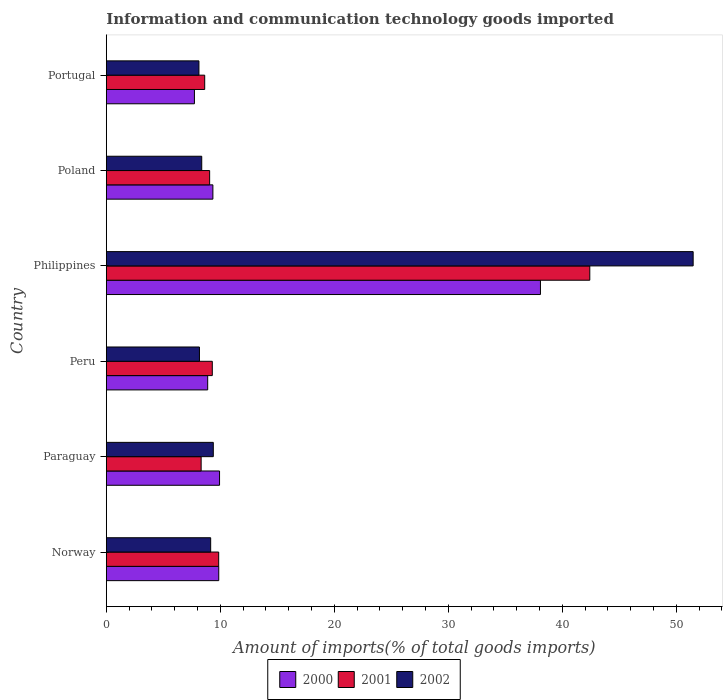How many different coloured bars are there?
Give a very brief answer. 3. Are the number of bars on each tick of the Y-axis equal?
Ensure brevity in your answer.  Yes. How many bars are there on the 2nd tick from the bottom?
Keep it short and to the point. 3. What is the label of the 6th group of bars from the top?
Give a very brief answer. Norway. What is the amount of goods imported in 2000 in Paraguay?
Provide a short and direct response. 9.93. Across all countries, what is the maximum amount of goods imported in 2000?
Offer a terse response. 38.08. Across all countries, what is the minimum amount of goods imported in 2000?
Your answer should be very brief. 7.73. What is the total amount of goods imported in 2001 in the graph?
Make the answer very short. 87.57. What is the difference between the amount of goods imported in 2001 in Philippines and that in Portugal?
Make the answer very short. 33.78. What is the difference between the amount of goods imported in 2000 in Norway and the amount of goods imported in 2001 in Portugal?
Your response must be concise. 1.23. What is the average amount of goods imported in 2002 per country?
Offer a very short reply. 15.78. What is the difference between the amount of goods imported in 2001 and amount of goods imported in 2000 in Norway?
Your answer should be compact. -0.01. What is the ratio of the amount of goods imported in 2002 in Norway to that in Peru?
Ensure brevity in your answer.  1.12. Is the amount of goods imported in 2001 in Peru less than that in Philippines?
Give a very brief answer. Yes. What is the difference between the highest and the second highest amount of goods imported in 2000?
Offer a very short reply. 28.15. What is the difference between the highest and the lowest amount of goods imported in 2001?
Your answer should be very brief. 34.09. In how many countries, is the amount of goods imported in 2001 greater than the average amount of goods imported in 2001 taken over all countries?
Your answer should be very brief. 1. Is the sum of the amount of goods imported in 2002 in Philippines and Portugal greater than the maximum amount of goods imported in 2001 across all countries?
Provide a succinct answer. Yes. Is it the case that in every country, the sum of the amount of goods imported in 2000 and amount of goods imported in 2001 is greater than the amount of goods imported in 2002?
Provide a short and direct response. Yes. How many bars are there?
Offer a very short reply. 18. How many countries are there in the graph?
Make the answer very short. 6. What is the difference between two consecutive major ticks on the X-axis?
Provide a short and direct response. 10. Are the values on the major ticks of X-axis written in scientific E-notation?
Offer a very short reply. No. Does the graph contain any zero values?
Your answer should be compact. No. What is the title of the graph?
Your answer should be very brief. Information and communication technology goods imported. Does "1974" appear as one of the legend labels in the graph?
Ensure brevity in your answer.  No. What is the label or title of the X-axis?
Your response must be concise. Amount of imports(% of total goods imports). What is the Amount of imports(% of total goods imports) in 2000 in Norway?
Offer a terse response. 9.86. What is the Amount of imports(% of total goods imports) in 2001 in Norway?
Ensure brevity in your answer.  9.86. What is the Amount of imports(% of total goods imports) of 2002 in Norway?
Give a very brief answer. 9.15. What is the Amount of imports(% of total goods imports) in 2000 in Paraguay?
Give a very brief answer. 9.93. What is the Amount of imports(% of total goods imports) of 2001 in Paraguay?
Offer a very short reply. 8.32. What is the Amount of imports(% of total goods imports) of 2002 in Paraguay?
Provide a succinct answer. 9.38. What is the Amount of imports(% of total goods imports) of 2000 in Peru?
Your answer should be compact. 8.89. What is the Amount of imports(% of total goods imports) in 2001 in Peru?
Your answer should be very brief. 9.3. What is the Amount of imports(% of total goods imports) of 2002 in Peru?
Give a very brief answer. 8.17. What is the Amount of imports(% of total goods imports) of 2000 in Philippines?
Provide a succinct answer. 38.08. What is the Amount of imports(% of total goods imports) in 2001 in Philippines?
Provide a short and direct response. 42.41. What is the Amount of imports(% of total goods imports) in 2002 in Philippines?
Your answer should be very brief. 51.48. What is the Amount of imports(% of total goods imports) in 2000 in Poland?
Give a very brief answer. 9.35. What is the Amount of imports(% of total goods imports) of 2001 in Poland?
Your answer should be very brief. 9.06. What is the Amount of imports(% of total goods imports) in 2002 in Poland?
Ensure brevity in your answer.  8.37. What is the Amount of imports(% of total goods imports) of 2000 in Portugal?
Ensure brevity in your answer.  7.73. What is the Amount of imports(% of total goods imports) in 2001 in Portugal?
Keep it short and to the point. 8.63. What is the Amount of imports(% of total goods imports) in 2002 in Portugal?
Give a very brief answer. 8.12. Across all countries, what is the maximum Amount of imports(% of total goods imports) in 2000?
Your answer should be compact. 38.08. Across all countries, what is the maximum Amount of imports(% of total goods imports) of 2001?
Your answer should be compact. 42.41. Across all countries, what is the maximum Amount of imports(% of total goods imports) in 2002?
Offer a terse response. 51.48. Across all countries, what is the minimum Amount of imports(% of total goods imports) of 2000?
Make the answer very short. 7.73. Across all countries, what is the minimum Amount of imports(% of total goods imports) in 2001?
Your answer should be compact. 8.32. Across all countries, what is the minimum Amount of imports(% of total goods imports) of 2002?
Ensure brevity in your answer.  8.12. What is the total Amount of imports(% of total goods imports) of 2000 in the graph?
Your answer should be compact. 83.84. What is the total Amount of imports(% of total goods imports) in 2001 in the graph?
Provide a short and direct response. 87.57. What is the total Amount of imports(% of total goods imports) of 2002 in the graph?
Keep it short and to the point. 94.67. What is the difference between the Amount of imports(% of total goods imports) of 2000 in Norway and that in Paraguay?
Offer a terse response. -0.07. What is the difference between the Amount of imports(% of total goods imports) of 2001 in Norway and that in Paraguay?
Your answer should be very brief. 1.54. What is the difference between the Amount of imports(% of total goods imports) in 2002 in Norway and that in Paraguay?
Provide a short and direct response. -0.23. What is the difference between the Amount of imports(% of total goods imports) in 2000 in Norway and that in Peru?
Your answer should be compact. 0.97. What is the difference between the Amount of imports(% of total goods imports) of 2001 in Norway and that in Peru?
Your answer should be very brief. 0.56. What is the difference between the Amount of imports(% of total goods imports) of 2002 in Norway and that in Peru?
Give a very brief answer. 0.98. What is the difference between the Amount of imports(% of total goods imports) in 2000 in Norway and that in Philippines?
Offer a terse response. -28.22. What is the difference between the Amount of imports(% of total goods imports) of 2001 in Norway and that in Philippines?
Offer a very short reply. -32.56. What is the difference between the Amount of imports(% of total goods imports) in 2002 in Norway and that in Philippines?
Provide a short and direct response. -42.32. What is the difference between the Amount of imports(% of total goods imports) in 2000 in Norway and that in Poland?
Make the answer very short. 0.51. What is the difference between the Amount of imports(% of total goods imports) of 2001 in Norway and that in Poland?
Keep it short and to the point. 0.79. What is the difference between the Amount of imports(% of total goods imports) of 2002 in Norway and that in Poland?
Your response must be concise. 0.78. What is the difference between the Amount of imports(% of total goods imports) of 2000 in Norway and that in Portugal?
Your answer should be very brief. 2.14. What is the difference between the Amount of imports(% of total goods imports) in 2001 in Norway and that in Portugal?
Offer a very short reply. 1.23. What is the difference between the Amount of imports(% of total goods imports) in 2002 in Norway and that in Portugal?
Ensure brevity in your answer.  1.03. What is the difference between the Amount of imports(% of total goods imports) in 2000 in Paraguay and that in Peru?
Ensure brevity in your answer.  1.04. What is the difference between the Amount of imports(% of total goods imports) in 2001 in Paraguay and that in Peru?
Your answer should be very brief. -0.98. What is the difference between the Amount of imports(% of total goods imports) in 2002 in Paraguay and that in Peru?
Your answer should be very brief. 1.21. What is the difference between the Amount of imports(% of total goods imports) in 2000 in Paraguay and that in Philippines?
Offer a very short reply. -28.15. What is the difference between the Amount of imports(% of total goods imports) in 2001 in Paraguay and that in Philippines?
Give a very brief answer. -34.09. What is the difference between the Amount of imports(% of total goods imports) of 2002 in Paraguay and that in Philippines?
Your response must be concise. -42.09. What is the difference between the Amount of imports(% of total goods imports) in 2000 in Paraguay and that in Poland?
Keep it short and to the point. 0.58. What is the difference between the Amount of imports(% of total goods imports) in 2001 in Paraguay and that in Poland?
Ensure brevity in your answer.  -0.75. What is the difference between the Amount of imports(% of total goods imports) in 2002 in Paraguay and that in Poland?
Offer a terse response. 1.01. What is the difference between the Amount of imports(% of total goods imports) in 2000 in Paraguay and that in Portugal?
Offer a very short reply. 2.2. What is the difference between the Amount of imports(% of total goods imports) in 2001 in Paraguay and that in Portugal?
Give a very brief answer. -0.31. What is the difference between the Amount of imports(% of total goods imports) of 2002 in Paraguay and that in Portugal?
Provide a succinct answer. 1.26. What is the difference between the Amount of imports(% of total goods imports) of 2000 in Peru and that in Philippines?
Provide a short and direct response. -29.19. What is the difference between the Amount of imports(% of total goods imports) of 2001 in Peru and that in Philippines?
Provide a succinct answer. -33.12. What is the difference between the Amount of imports(% of total goods imports) in 2002 in Peru and that in Philippines?
Offer a very short reply. -43.31. What is the difference between the Amount of imports(% of total goods imports) of 2000 in Peru and that in Poland?
Your answer should be very brief. -0.46. What is the difference between the Amount of imports(% of total goods imports) in 2001 in Peru and that in Poland?
Your answer should be compact. 0.23. What is the difference between the Amount of imports(% of total goods imports) of 2002 in Peru and that in Poland?
Offer a terse response. -0.2. What is the difference between the Amount of imports(% of total goods imports) in 2000 in Peru and that in Portugal?
Give a very brief answer. 1.16. What is the difference between the Amount of imports(% of total goods imports) in 2001 in Peru and that in Portugal?
Make the answer very short. 0.67. What is the difference between the Amount of imports(% of total goods imports) in 2002 in Peru and that in Portugal?
Offer a very short reply. 0.05. What is the difference between the Amount of imports(% of total goods imports) in 2000 in Philippines and that in Poland?
Give a very brief answer. 28.73. What is the difference between the Amount of imports(% of total goods imports) in 2001 in Philippines and that in Poland?
Provide a succinct answer. 33.35. What is the difference between the Amount of imports(% of total goods imports) of 2002 in Philippines and that in Poland?
Your answer should be compact. 43.11. What is the difference between the Amount of imports(% of total goods imports) in 2000 in Philippines and that in Portugal?
Make the answer very short. 30.36. What is the difference between the Amount of imports(% of total goods imports) in 2001 in Philippines and that in Portugal?
Make the answer very short. 33.78. What is the difference between the Amount of imports(% of total goods imports) of 2002 in Philippines and that in Portugal?
Offer a very short reply. 43.35. What is the difference between the Amount of imports(% of total goods imports) of 2000 in Poland and that in Portugal?
Your answer should be very brief. 1.62. What is the difference between the Amount of imports(% of total goods imports) in 2001 in Poland and that in Portugal?
Keep it short and to the point. 0.43. What is the difference between the Amount of imports(% of total goods imports) in 2002 in Poland and that in Portugal?
Ensure brevity in your answer.  0.25. What is the difference between the Amount of imports(% of total goods imports) of 2000 in Norway and the Amount of imports(% of total goods imports) of 2001 in Paraguay?
Your answer should be very brief. 1.55. What is the difference between the Amount of imports(% of total goods imports) of 2000 in Norway and the Amount of imports(% of total goods imports) of 2002 in Paraguay?
Offer a very short reply. 0.48. What is the difference between the Amount of imports(% of total goods imports) in 2001 in Norway and the Amount of imports(% of total goods imports) in 2002 in Paraguay?
Offer a very short reply. 0.47. What is the difference between the Amount of imports(% of total goods imports) of 2000 in Norway and the Amount of imports(% of total goods imports) of 2001 in Peru?
Your response must be concise. 0.57. What is the difference between the Amount of imports(% of total goods imports) of 2000 in Norway and the Amount of imports(% of total goods imports) of 2002 in Peru?
Provide a succinct answer. 1.69. What is the difference between the Amount of imports(% of total goods imports) of 2001 in Norway and the Amount of imports(% of total goods imports) of 2002 in Peru?
Offer a very short reply. 1.69. What is the difference between the Amount of imports(% of total goods imports) in 2000 in Norway and the Amount of imports(% of total goods imports) in 2001 in Philippines?
Provide a short and direct response. -32.55. What is the difference between the Amount of imports(% of total goods imports) of 2000 in Norway and the Amount of imports(% of total goods imports) of 2002 in Philippines?
Give a very brief answer. -41.62. What is the difference between the Amount of imports(% of total goods imports) of 2001 in Norway and the Amount of imports(% of total goods imports) of 2002 in Philippines?
Your answer should be very brief. -41.62. What is the difference between the Amount of imports(% of total goods imports) of 2000 in Norway and the Amount of imports(% of total goods imports) of 2001 in Poland?
Ensure brevity in your answer.  0.8. What is the difference between the Amount of imports(% of total goods imports) in 2000 in Norway and the Amount of imports(% of total goods imports) in 2002 in Poland?
Give a very brief answer. 1.49. What is the difference between the Amount of imports(% of total goods imports) in 2001 in Norway and the Amount of imports(% of total goods imports) in 2002 in Poland?
Your answer should be compact. 1.49. What is the difference between the Amount of imports(% of total goods imports) of 2000 in Norway and the Amount of imports(% of total goods imports) of 2001 in Portugal?
Ensure brevity in your answer.  1.23. What is the difference between the Amount of imports(% of total goods imports) of 2000 in Norway and the Amount of imports(% of total goods imports) of 2002 in Portugal?
Your response must be concise. 1.74. What is the difference between the Amount of imports(% of total goods imports) in 2001 in Norway and the Amount of imports(% of total goods imports) in 2002 in Portugal?
Provide a short and direct response. 1.73. What is the difference between the Amount of imports(% of total goods imports) in 2000 in Paraguay and the Amount of imports(% of total goods imports) in 2001 in Peru?
Offer a terse response. 0.64. What is the difference between the Amount of imports(% of total goods imports) of 2000 in Paraguay and the Amount of imports(% of total goods imports) of 2002 in Peru?
Offer a very short reply. 1.76. What is the difference between the Amount of imports(% of total goods imports) of 2001 in Paraguay and the Amount of imports(% of total goods imports) of 2002 in Peru?
Your answer should be compact. 0.15. What is the difference between the Amount of imports(% of total goods imports) in 2000 in Paraguay and the Amount of imports(% of total goods imports) in 2001 in Philippines?
Your answer should be compact. -32.48. What is the difference between the Amount of imports(% of total goods imports) in 2000 in Paraguay and the Amount of imports(% of total goods imports) in 2002 in Philippines?
Offer a very short reply. -41.55. What is the difference between the Amount of imports(% of total goods imports) in 2001 in Paraguay and the Amount of imports(% of total goods imports) in 2002 in Philippines?
Your response must be concise. -43.16. What is the difference between the Amount of imports(% of total goods imports) in 2000 in Paraguay and the Amount of imports(% of total goods imports) in 2001 in Poland?
Give a very brief answer. 0.87. What is the difference between the Amount of imports(% of total goods imports) of 2000 in Paraguay and the Amount of imports(% of total goods imports) of 2002 in Poland?
Your answer should be compact. 1.56. What is the difference between the Amount of imports(% of total goods imports) in 2001 in Paraguay and the Amount of imports(% of total goods imports) in 2002 in Poland?
Your answer should be very brief. -0.05. What is the difference between the Amount of imports(% of total goods imports) of 2000 in Paraguay and the Amount of imports(% of total goods imports) of 2001 in Portugal?
Give a very brief answer. 1.3. What is the difference between the Amount of imports(% of total goods imports) of 2000 in Paraguay and the Amount of imports(% of total goods imports) of 2002 in Portugal?
Your answer should be compact. 1.81. What is the difference between the Amount of imports(% of total goods imports) in 2001 in Paraguay and the Amount of imports(% of total goods imports) in 2002 in Portugal?
Your response must be concise. 0.19. What is the difference between the Amount of imports(% of total goods imports) in 2000 in Peru and the Amount of imports(% of total goods imports) in 2001 in Philippines?
Your response must be concise. -33.52. What is the difference between the Amount of imports(% of total goods imports) of 2000 in Peru and the Amount of imports(% of total goods imports) of 2002 in Philippines?
Offer a terse response. -42.59. What is the difference between the Amount of imports(% of total goods imports) of 2001 in Peru and the Amount of imports(% of total goods imports) of 2002 in Philippines?
Offer a terse response. -42.18. What is the difference between the Amount of imports(% of total goods imports) of 2000 in Peru and the Amount of imports(% of total goods imports) of 2001 in Poland?
Provide a succinct answer. -0.17. What is the difference between the Amount of imports(% of total goods imports) of 2000 in Peru and the Amount of imports(% of total goods imports) of 2002 in Poland?
Your answer should be very brief. 0.52. What is the difference between the Amount of imports(% of total goods imports) of 2001 in Peru and the Amount of imports(% of total goods imports) of 2002 in Poland?
Your answer should be very brief. 0.93. What is the difference between the Amount of imports(% of total goods imports) of 2000 in Peru and the Amount of imports(% of total goods imports) of 2001 in Portugal?
Give a very brief answer. 0.26. What is the difference between the Amount of imports(% of total goods imports) of 2000 in Peru and the Amount of imports(% of total goods imports) of 2002 in Portugal?
Make the answer very short. 0.77. What is the difference between the Amount of imports(% of total goods imports) in 2001 in Peru and the Amount of imports(% of total goods imports) in 2002 in Portugal?
Make the answer very short. 1.17. What is the difference between the Amount of imports(% of total goods imports) of 2000 in Philippines and the Amount of imports(% of total goods imports) of 2001 in Poland?
Give a very brief answer. 29.02. What is the difference between the Amount of imports(% of total goods imports) in 2000 in Philippines and the Amount of imports(% of total goods imports) in 2002 in Poland?
Ensure brevity in your answer.  29.71. What is the difference between the Amount of imports(% of total goods imports) in 2001 in Philippines and the Amount of imports(% of total goods imports) in 2002 in Poland?
Your answer should be compact. 34.04. What is the difference between the Amount of imports(% of total goods imports) in 2000 in Philippines and the Amount of imports(% of total goods imports) in 2001 in Portugal?
Give a very brief answer. 29.45. What is the difference between the Amount of imports(% of total goods imports) of 2000 in Philippines and the Amount of imports(% of total goods imports) of 2002 in Portugal?
Give a very brief answer. 29.96. What is the difference between the Amount of imports(% of total goods imports) of 2001 in Philippines and the Amount of imports(% of total goods imports) of 2002 in Portugal?
Keep it short and to the point. 34.29. What is the difference between the Amount of imports(% of total goods imports) of 2000 in Poland and the Amount of imports(% of total goods imports) of 2001 in Portugal?
Provide a short and direct response. 0.72. What is the difference between the Amount of imports(% of total goods imports) in 2000 in Poland and the Amount of imports(% of total goods imports) in 2002 in Portugal?
Your answer should be very brief. 1.23. What is the difference between the Amount of imports(% of total goods imports) in 2001 in Poland and the Amount of imports(% of total goods imports) in 2002 in Portugal?
Ensure brevity in your answer.  0.94. What is the average Amount of imports(% of total goods imports) of 2000 per country?
Provide a short and direct response. 13.97. What is the average Amount of imports(% of total goods imports) of 2001 per country?
Ensure brevity in your answer.  14.6. What is the average Amount of imports(% of total goods imports) of 2002 per country?
Ensure brevity in your answer.  15.78. What is the difference between the Amount of imports(% of total goods imports) in 2000 and Amount of imports(% of total goods imports) in 2001 in Norway?
Make the answer very short. 0.01. What is the difference between the Amount of imports(% of total goods imports) in 2000 and Amount of imports(% of total goods imports) in 2002 in Norway?
Your answer should be very brief. 0.71. What is the difference between the Amount of imports(% of total goods imports) in 2001 and Amount of imports(% of total goods imports) in 2002 in Norway?
Provide a succinct answer. 0.7. What is the difference between the Amount of imports(% of total goods imports) of 2000 and Amount of imports(% of total goods imports) of 2001 in Paraguay?
Give a very brief answer. 1.61. What is the difference between the Amount of imports(% of total goods imports) in 2000 and Amount of imports(% of total goods imports) in 2002 in Paraguay?
Offer a terse response. 0.55. What is the difference between the Amount of imports(% of total goods imports) of 2001 and Amount of imports(% of total goods imports) of 2002 in Paraguay?
Give a very brief answer. -1.07. What is the difference between the Amount of imports(% of total goods imports) in 2000 and Amount of imports(% of total goods imports) in 2001 in Peru?
Ensure brevity in your answer.  -0.4. What is the difference between the Amount of imports(% of total goods imports) of 2000 and Amount of imports(% of total goods imports) of 2002 in Peru?
Offer a very short reply. 0.72. What is the difference between the Amount of imports(% of total goods imports) in 2001 and Amount of imports(% of total goods imports) in 2002 in Peru?
Provide a short and direct response. 1.13. What is the difference between the Amount of imports(% of total goods imports) in 2000 and Amount of imports(% of total goods imports) in 2001 in Philippines?
Keep it short and to the point. -4.33. What is the difference between the Amount of imports(% of total goods imports) of 2000 and Amount of imports(% of total goods imports) of 2002 in Philippines?
Provide a succinct answer. -13.39. What is the difference between the Amount of imports(% of total goods imports) in 2001 and Amount of imports(% of total goods imports) in 2002 in Philippines?
Your answer should be very brief. -9.07. What is the difference between the Amount of imports(% of total goods imports) of 2000 and Amount of imports(% of total goods imports) of 2001 in Poland?
Offer a very short reply. 0.29. What is the difference between the Amount of imports(% of total goods imports) in 2000 and Amount of imports(% of total goods imports) in 2002 in Poland?
Offer a terse response. 0.98. What is the difference between the Amount of imports(% of total goods imports) in 2001 and Amount of imports(% of total goods imports) in 2002 in Poland?
Offer a very short reply. 0.69. What is the difference between the Amount of imports(% of total goods imports) in 2000 and Amount of imports(% of total goods imports) in 2001 in Portugal?
Your answer should be very brief. -0.9. What is the difference between the Amount of imports(% of total goods imports) in 2000 and Amount of imports(% of total goods imports) in 2002 in Portugal?
Your answer should be compact. -0.4. What is the difference between the Amount of imports(% of total goods imports) in 2001 and Amount of imports(% of total goods imports) in 2002 in Portugal?
Your answer should be compact. 0.51. What is the ratio of the Amount of imports(% of total goods imports) in 2001 in Norway to that in Paraguay?
Your answer should be compact. 1.19. What is the ratio of the Amount of imports(% of total goods imports) of 2002 in Norway to that in Paraguay?
Give a very brief answer. 0.98. What is the ratio of the Amount of imports(% of total goods imports) in 2000 in Norway to that in Peru?
Your answer should be very brief. 1.11. What is the ratio of the Amount of imports(% of total goods imports) in 2001 in Norway to that in Peru?
Keep it short and to the point. 1.06. What is the ratio of the Amount of imports(% of total goods imports) of 2002 in Norway to that in Peru?
Make the answer very short. 1.12. What is the ratio of the Amount of imports(% of total goods imports) in 2000 in Norway to that in Philippines?
Your answer should be very brief. 0.26. What is the ratio of the Amount of imports(% of total goods imports) of 2001 in Norway to that in Philippines?
Your response must be concise. 0.23. What is the ratio of the Amount of imports(% of total goods imports) in 2002 in Norway to that in Philippines?
Give a very brief answer. 0.18. What is the ratio of the Amount of imports(% of total goods imports) in 2000 in Norway to that in Poland?
Your response must be concise. 1.05. What is the ratio of the Amount of imports(% of total goods imports) in 2001 in Norway to that in Poland?
Offer a very short reply. 1.09. What is the ratio of the Amount of imports(% of total goods imports) in 2002 in Norway to that in Poland?
Your answer should be compact. 1.09. What is the ratio of the Amount of imports(% of total goods imports) in 2000 in Norway to that in Portugal?
Ensure brevity in your answer.  1.28. What is the ratio of the Amount of imports(% of total goods imports) in 2001 in Norway to that in Portugal?
Offer a very short reply. 1.14. What is the ratio of the Amount of imports(% of total goods imports) of 2002 in Norway to that in Portugal?
Your answer should be very brief. 1.13. What is the ratio of the Amount of imports(% of total goods imports) of 2000 in Paraguay to that in Peru?
Your response must be concise. 1.12. What is the ratio of the Amount of imports(% of total goods imports) in 2001 in Paraguay to that in Peru?
Keep it short and to the point. 0.89. What is the ratio of the Amount of imports(% of total goods imports) of 2002 in Paraguay to that in Peru?
Your answer should be compact. 1.15. What is the ratio of the Amount of imports(% of total goods imports) of 2000 in Paraguay to that in Philippines?
Ensure brevity in your answer.  0.26. What is the ratio of the Amount of imports(% of total goods imports) of 2001 in Paraguay to that in Philippines?
Provide a short and direct response. 0.2. What is the ratio of the Amount of imports(% of total goods imports) in 2002 in Paraguay to that in Philippines?
Ensure brevity in your answer.  0.18. What is the ratio of the Amount of imports(% of total goods imports) in 2000 in Paraguay to that in Poland?
Keep it short and to the point. 1.06. What is the ratio of the Amount of imports(% of total goods imports) of 2001 in Paraguay to that in Poland?
Your answer should be compact. 0.92. What is the ratio of the Amount of imports(% of total goods imports) in 2002 in Paraguay to that in Poland?
Your answer should be compact. 1.12. What is the ratio of the Amount of imports(% of total goods imports) of 2000 in Paraguay to that in Portugal?
Provide a short and direct response. 1.29. What is the ratio of the Amount of imports(% of total goods imports) of 2001 in Paraguay to that in Portugal?
Offer a terse response. 0.96. What is the ratio of the Amount of imports(% of total goods imports) of 2002 in Paraguay to that in Portugal?
Ensure brevity in your answer.  1.16. What is the ratio of the Amount of imports(% of total goods imports) in 2000 in Peru to that in Philippines?
Offer a terse response. 0.23. What is the ratio of the Amount of imports(% of total goods imports) of 2001 in Peru to that in Philippines?
Provide a short and direct response. 0.22. What is the ratio of the Amount of imports(% of total goods imports) of 2002 in Peru to that in Philippines?
Offer a terse response. 0.16. What is the ratio of the Amount of imports(% of total goods imports) in 2000 in Peru to that in Poland?
Your response must be concise. 0.95. What is the ratio of the Amount of imports(% of total goods imports) in 2001 in Peru to that in Poland?
Ensure brevity in your answer.  1.03. What is the ratio of the Amount of imports(% of total goods imports) of 2002 in Peru to that in Poland?
Keep it short and to the point. 0.98. What is the ratio of the Amount of imports(% of total goods imports) of 2000 in Peru to that in Portugal?
Give a very brief answer. 1.15. What is the ratio of the Amount of imports(% of total goods imports) in 2001 in Peru to that in Portugal?
Provide a short and direct response. 1.08. What is the ratio of the Amount of imports(% of total goods imports) in 2002 in Peru to that in Portugal?
Make the answer very short. 1.01. What is the ratio of the Amount of imports(% of total goods imports) in 2000 in Philippines to that in Poland?
Provide a short and direct response. 4.07. What is the ratio of the Amount of imports(% of total goods imports) in 2001 in Philippines to that in Poland?
Your response must be concise. 4.68. What is the ratio of the Amount of imports(% of total goods imports) in 2002 in Philippines to that in Poland?
Provide a short and direct response. 6.15. What is the ratio of the Amount of imports(% of total goods imports) in 2000 in Philippines to that in Portugal?
Provide a succinct answer. 4.93. What is the ratio of the Amount of imports(% of total goods imports) of 2001 in Philippines to that in Portugal?
Keep it short and to the point. 4.91. What is the ratio of the Amount of imports(% of total goods imports) of 2002 in Philippines to that in Portugal?
Make the answer very short. 6.34. What is the ratio of the Amount of imports(% of total goods imports) in 2000 in Poland to that in Portugal?
Give a very brief answer. 1.21. What is the ratio of the Amount of imports(% of total goods imports) of 2001 in Poland to that in Portugal?
Your answer should be very brief. 1.05. What is the ratio of the Amount of imports(% of total goods imports) in 2002 in Poland to that in Portugal?
Your response must be concise. 1.03. What is the difference between the highest and the second highest Amount of imports(% of total goods imports) in 2000?
Offer a very short reply. 28.15. What is the difference between the highest and the second highest Amount of imports(% of total goods imports) of 2001?
Provide a short and direct response. 32.56. What is the difference between the highest and the second highest Amount of imports(% of total goods imports) in 2002?
Provide a short and direct response. 42.09. What is the difference between the highest and the lowest Amount of imports(% of total goods imports) of 2000?
Provide a succinct answer. 30.36. What is the difference between the highest and the lowest Amount of imports(% of total goods imports) in 2001?
Give a very brief answer. 34.09. What is the difference between the highest and the lowest Amount of imports(% of total goods imports) in 2002?
Your answer should be very brief. 43.35. 